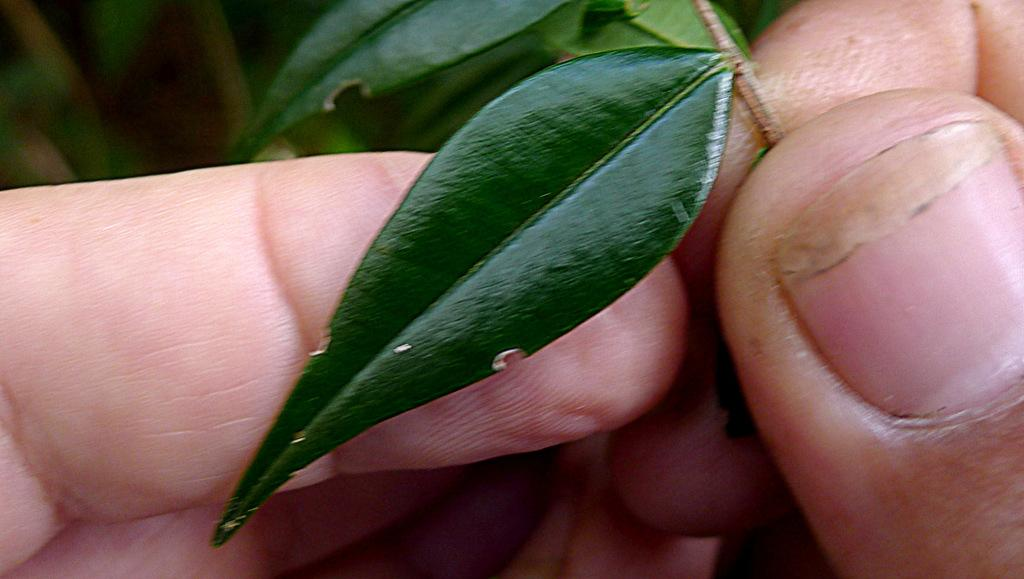What is the main subject of the image? There is a person in the image. What is the person holding in their hand? The person is holding curry leaves in their hand. Reasoning: Let' Let's think step by step in order to produce the conversation. We start by identifying the main subject of the image, which is the person. Then, we describe what the person is holding, which is curry leaves. We avoid asking questions that cannot be answered definitively with the information given and ensure that the language is simple and clear. Absurd Question/Answer: What type of stamp can be seen on the frame of the person's property in the image? There is no stamp, frame, or property visible in the image; it only features a person holding curry leaves. 